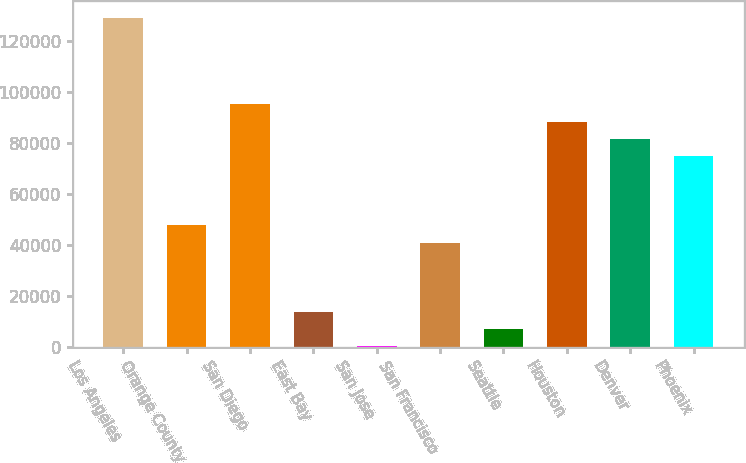<chart> <loc_0><loc_0><loc_500><loc_500><bar_chart><fcel>Los Angeles<fcel>Orange County<fcel>San Diego<fcel>East Bay<fcel>San Jose<fcel>San Francisco<fcel>Seattle<fcel>Houston<fcel>Denver<fcel>Phoenix<nl><fcel>128955<fcel>47651.1<fcel>95078.2<fcel>13774.6<fcel>224<fcel>40875.8<fcel>6999.3<fcel>88302.9<fcel>81527.6<fcel>74752.3<nl></chart> 